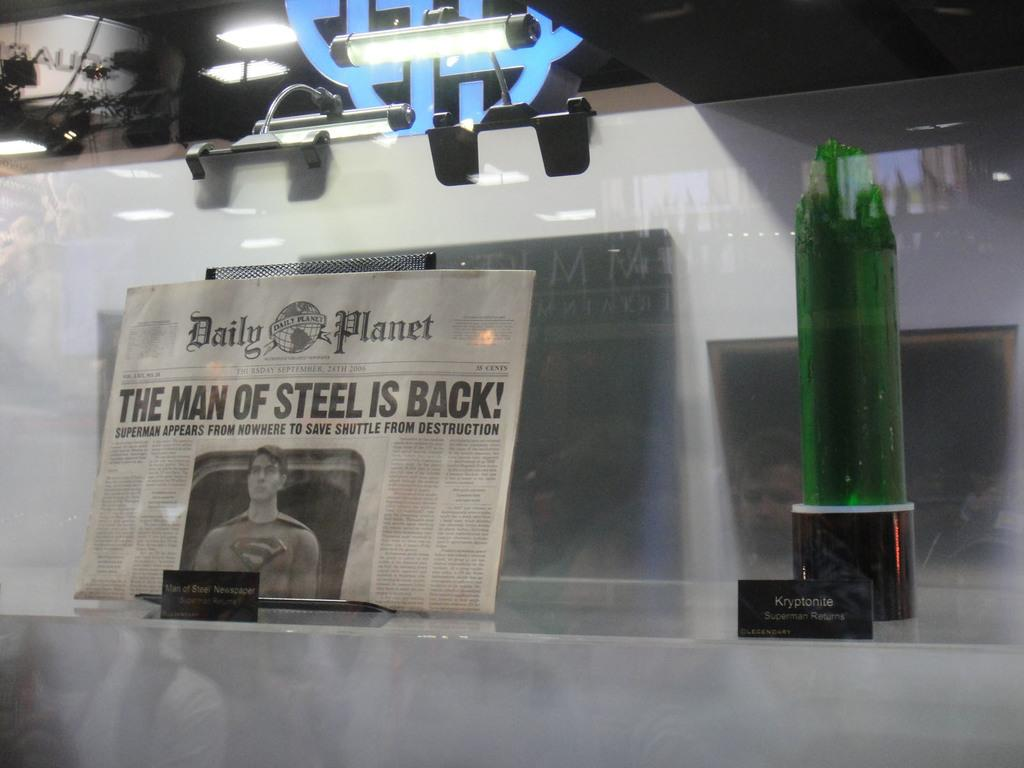Provide a one-sentence caption for the provided image. Daily Planet Newspaper that includes the man of steel is back. 